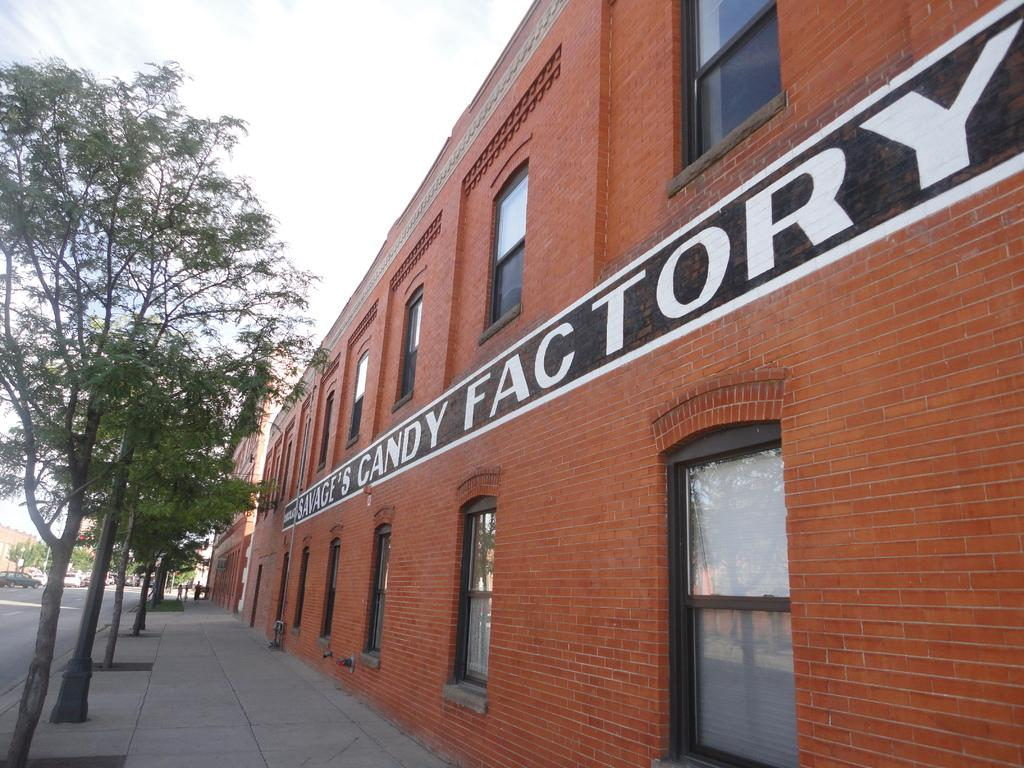What type of structures can be seen in the image? There are buildings in the image. What other natural elements are present in the image? There are trees in the image. What mode of transportation can be seen on the road in the image? There are vehicles on the road in the image. What surface is visible at the bottom of the image? The bottom of the image contains a floor. What is the price of the lawyer in the image? There is no lawyer present in the image, so it is not possible to determine the price. How does the walk in the image progress? There is no walk or walking activity depicted in the image. 